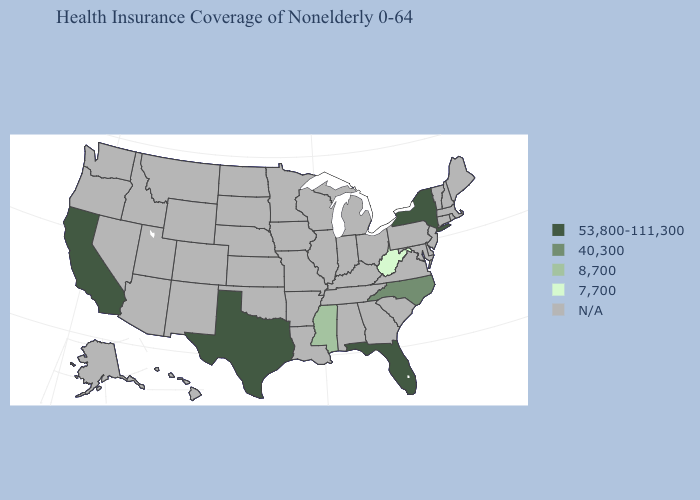What is the value of Virginia?
Write a very short answer. N/A. What is the lowest value in the South?
Be succinct. 7,700. Does the map have missing data?
Quick response, please. Yes. Name the states that have a value in the range 7,700?
Give a very brief answer. West Virginia. What is the lowest value in the USA?
Answer briefly. 7,700. What is the value of Missouri?
Keep it brief. N/A. What is the value of New Hampshire?
Give a very brief answer. N/A. Does West Virginia have the lowest value in the USA?
Quick response, please. Yes. Among the states that border Kentucky , which have the highest value?
Answer briefly. West Virginia. Name the states that have a value in the range 7,700?
Give a very brief answer. West Virginia. Which states have the highest value in the USA?
Quick response, please. California, Florida, New York, Texas. What is the value of Florida?
Answer briefly. 53,800-111,300. 